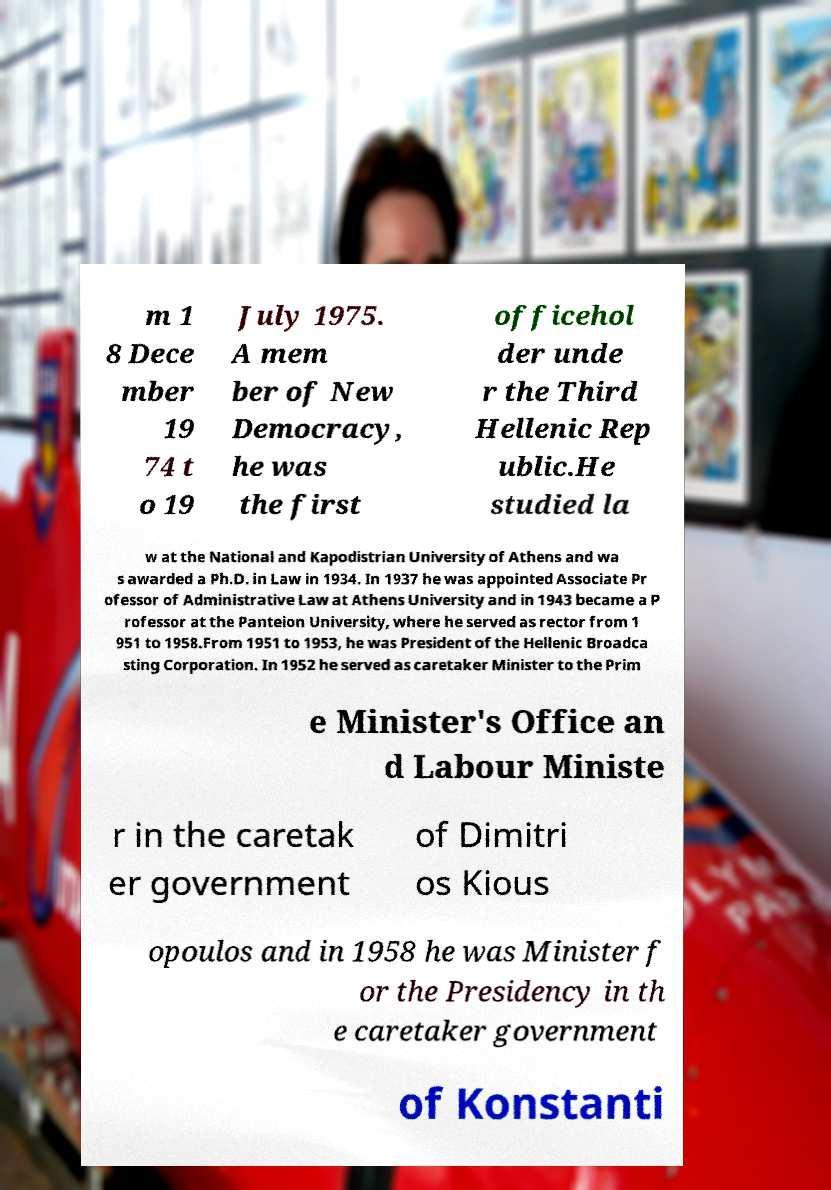Please identify and transcribe the text found in this image. m 1 8 Dece mber 19 74 t o 19 July 1975. A mem ber of New Democracy, he was the first officehol der unde r the Third Hellenic Rep ublic.He studied la w at the National and Kapodistrian University of Athens and wa s awarded a Ph.D. in Law in 1934. In 1937 he was appointed Associate Pr ofessor of Administrative Law at Athens University and in 1943 became a P rofessor at the Panteion University, where he served as rector from 1 951 to 1958.From 1951 to 1953, he was President of the Hellenic Broadca sting Corporation. In 1952 he served as caretaker Minister to the Prim e Minister's Office an d Labour Ministe r in the caretak er government of Dimitri os Kious opoulos and in 1958 he was Minister f or the Presidency in th e caretaker government of Konstanti 